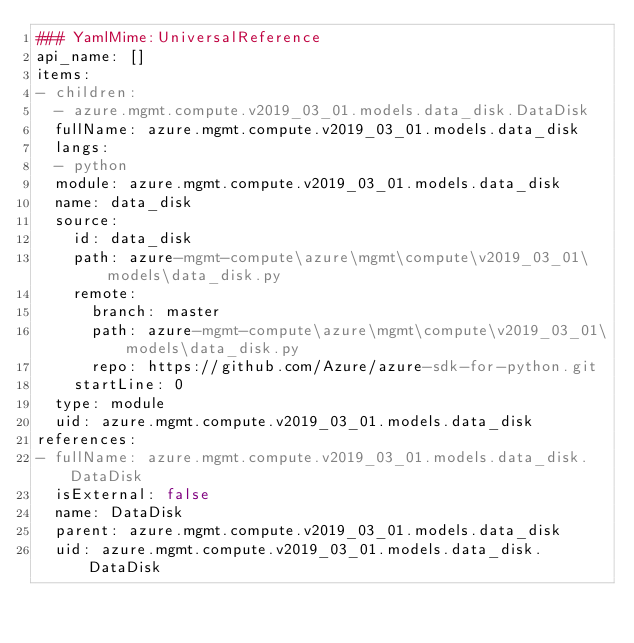<code> <loc_0><loc_0><loc_500><loc_500><_YAML_>### YamlMime:UniversalReference
api_name: []
items:
- children:
  - azure.mgmt.compute.v2019_03_01.models.data_disk.DataDisk
  fullName: azure.mgmt.compute.v2019_03_01.models.data_disk
  langs:
  - python
  module: azure.mgmt.compute.v2019_03_01.models.data_disk
  name: data_disk
  source:
    id: data_disk
    path: azure-mgmt-compute\azure\mgmt\compute\v2019_03_01\models\data_disk.py
    remote:
      branch: master
      path: azure-mgmt-compute\azure\mgmt\compute\v2019_03_01\models\data_disk.py
      repo: https://github.com/Azure/azure-sdk-for-python.git
    startLine: 0
  type: module
  uid: azure.mgmt.compute.v2019_03_01.models.data_disk
references:
- fullName: azure.mgmt.compute.v2019_03_01.models.data_disk.DataDisk
  isExternal: false
  name: DataDisk
  parent: azure.mgmt.compute.v2019_03_01.models.data_disk
  uid: azure.mgmt.compute.v2019_03_01.models.data_disk.DataDisk
</code> 